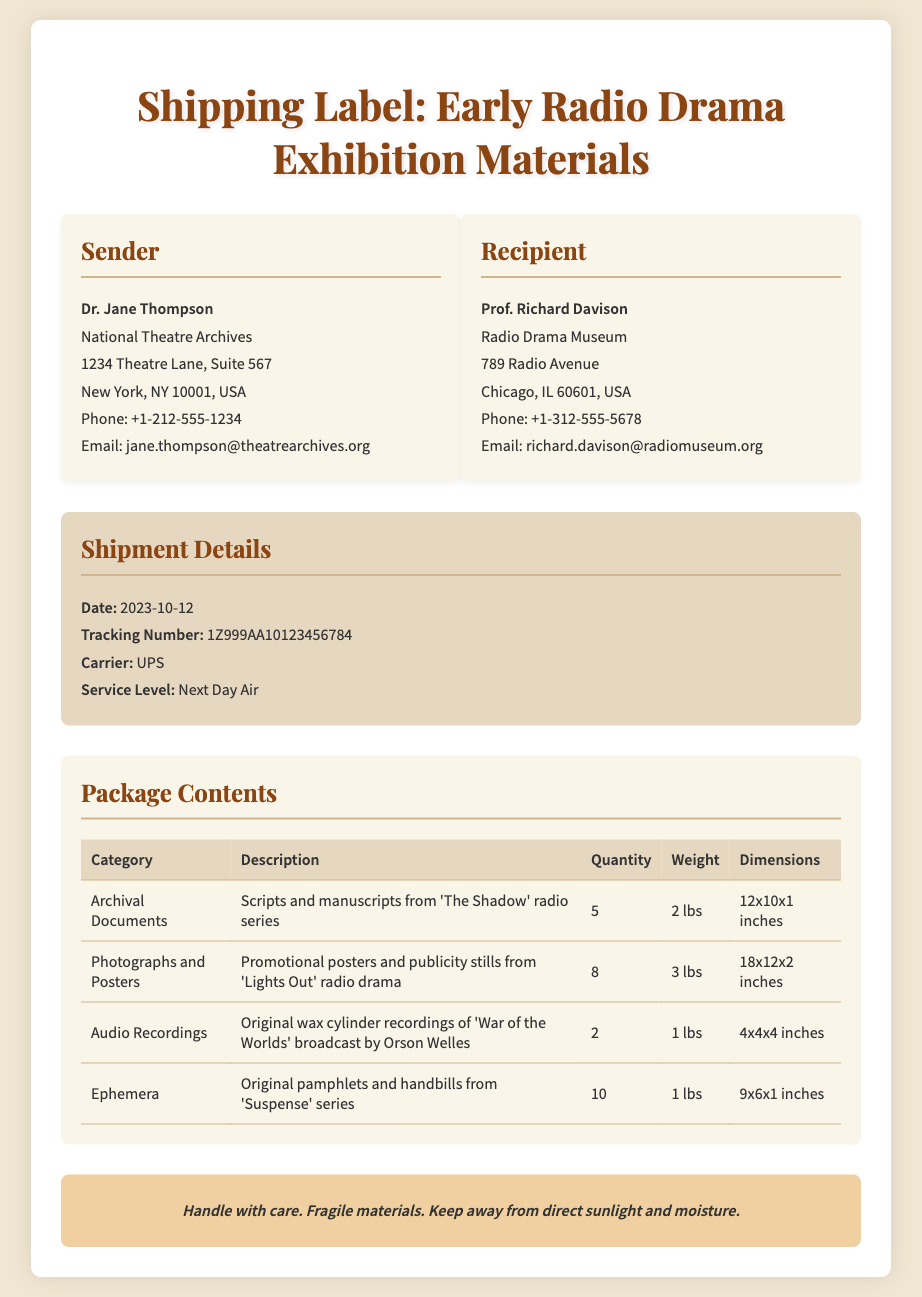what is the sender's name? The sender's name is listed at the top of the sender's section of the label, which is Dr. Jane Thompson.
Answer: Dr. Jane Thompson what is the recipient's phone number? The recipient's phone number is provided in the recipient's section, which is +1-312-555-5678.
Answer: +1-312-555-5678 when was the shipment sent? The shipment date is specified in the shipment details section as 2023-10-12.
Answer: 2023-10-12 how many audio recordings are included in the package? The quantity of audio recordings is listed in the package contents table, which is 2.
Answer: 2 what is the weight of the photographs and posters category? The weight for the photographs and posters is stated in the package contents table as 3 lbs.
Answer: 3 lbs who is the recipient of the shipment? The name of the recipient is found in the recipient's section, which is Prof. Richard Davison.
Answer: Prof. Richard Davison what type of service was used for shipping? The service level for the shipping is indicated in the shipment details section as Next Day Air.
Answer: Next Day Air what special instructions are provided for handling the package? The special instructions detail the handling precautions outlined at the bottom of the document: Handle with care. Fragile materials. Keep away from direct sunlight and moisture.
Answer: Handle with care. Fragile materials. Keep away from direct sunlight and moisture how many categories of items are listed in the package? The number of categories is determined by counting the rows in the package contents table, which lists 4 categories.
Answer: 4 